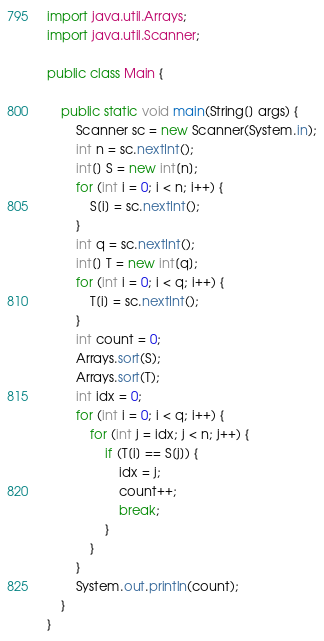<code> <loc_0><loc_0><loc_500><loc_500><_Java_>import java.util.Arrays;
import java.util.Scanner;

public class Main {

    public static void main(String[] args) {
        Scanner sc = new Scanner(System.in);
        int n = sc.nextInt();
        int[] S = new int[n];
        for (int i = 0; i < n; i++) {
            S[i] = sc.nextInt();
        }
        int q = sc.nextInt();
        int[] T = new int[q];
        for (int i = 0; i < q; i++) {
            T[i] = sc.nextInt();
        }
        int count = 0;
        Arrays.sort(S);
        Arrays.sort(T);
        int idx = 0;
        for (int i = 0; i < q; i++) {
            for (int j = idx; j < n; j++) {
                if (T[i] == S[j]) {
                    idx = j;
                    count++;
                    break;
                }
            }
        }
        System.out.println(count);
    }
}</code> 